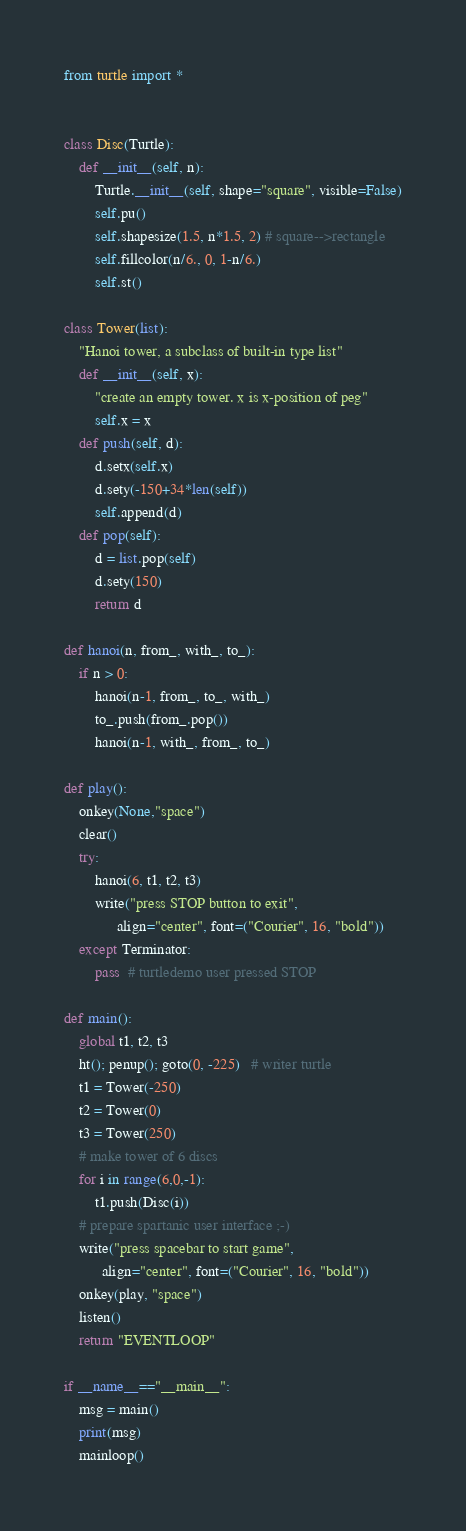Convert code to text. <code><loc_0><loc_0><loc_500><loc_500><_Python_>from turtle import *


class Disc(Turtle):
    def __init__(self, n):
        Turtle.__init__(self, shape="square", visible=False)
        self.pu()
        self.shapesize(1.5, n*1.5, 2) # square-->rectangle
        self.fillcolor(n/6., 0, 1-n/6.)
        self.st()

class Tower(list):
    "Hanoi tower, a subclass of built-in type list"
    def __init__(self, x):
        "create an empty tower. x is x-position of peg"
        self.x = x
    def push(self, d):
        d.setx(self.x)
        d.sety(-150+34*len(self))
        self.append(d)
    def pop(self):
        d = list.pop(self)
        d.sety(150)
        return d

def hanoi(n, from_, with_, to_):
    if n > 0:
        hanoi(n-1, from_, to_, with_)
        to_.push(from_.pop())
        hanoi(n-1, with_, from_, to_)

def play():
    onkey(None,"space")
    clear()
    try:
        hanoi(6, t1, t2, t3)
        write("press STOP button to exit",
              align="center", font=("Courier", 16, "bold"))
    except Terminator:
        pass  # turtledemo user pressed STOP

def main():
    global t1, t2, t3
    ht(); penup(); goto(0, -225)   # writer turtle
    t1 = Tower(-250)
    t2 = Tower(0)
    t3 = Tower(250)
    # make tower of 6 discs
    for i in range(6,0,-1):
        t1.push(Disc(i))
    # prepare spartanic user interface ;-)
    write("press spacebar to start game",
          align="center", font=("Courier", 16, "bold"))
    onkey(play, "space")
    listen()
    return "EVENTLOOP"

if __name__=="__main__":
    msg = main()
    print(msg)
    mainloop()

</code> 